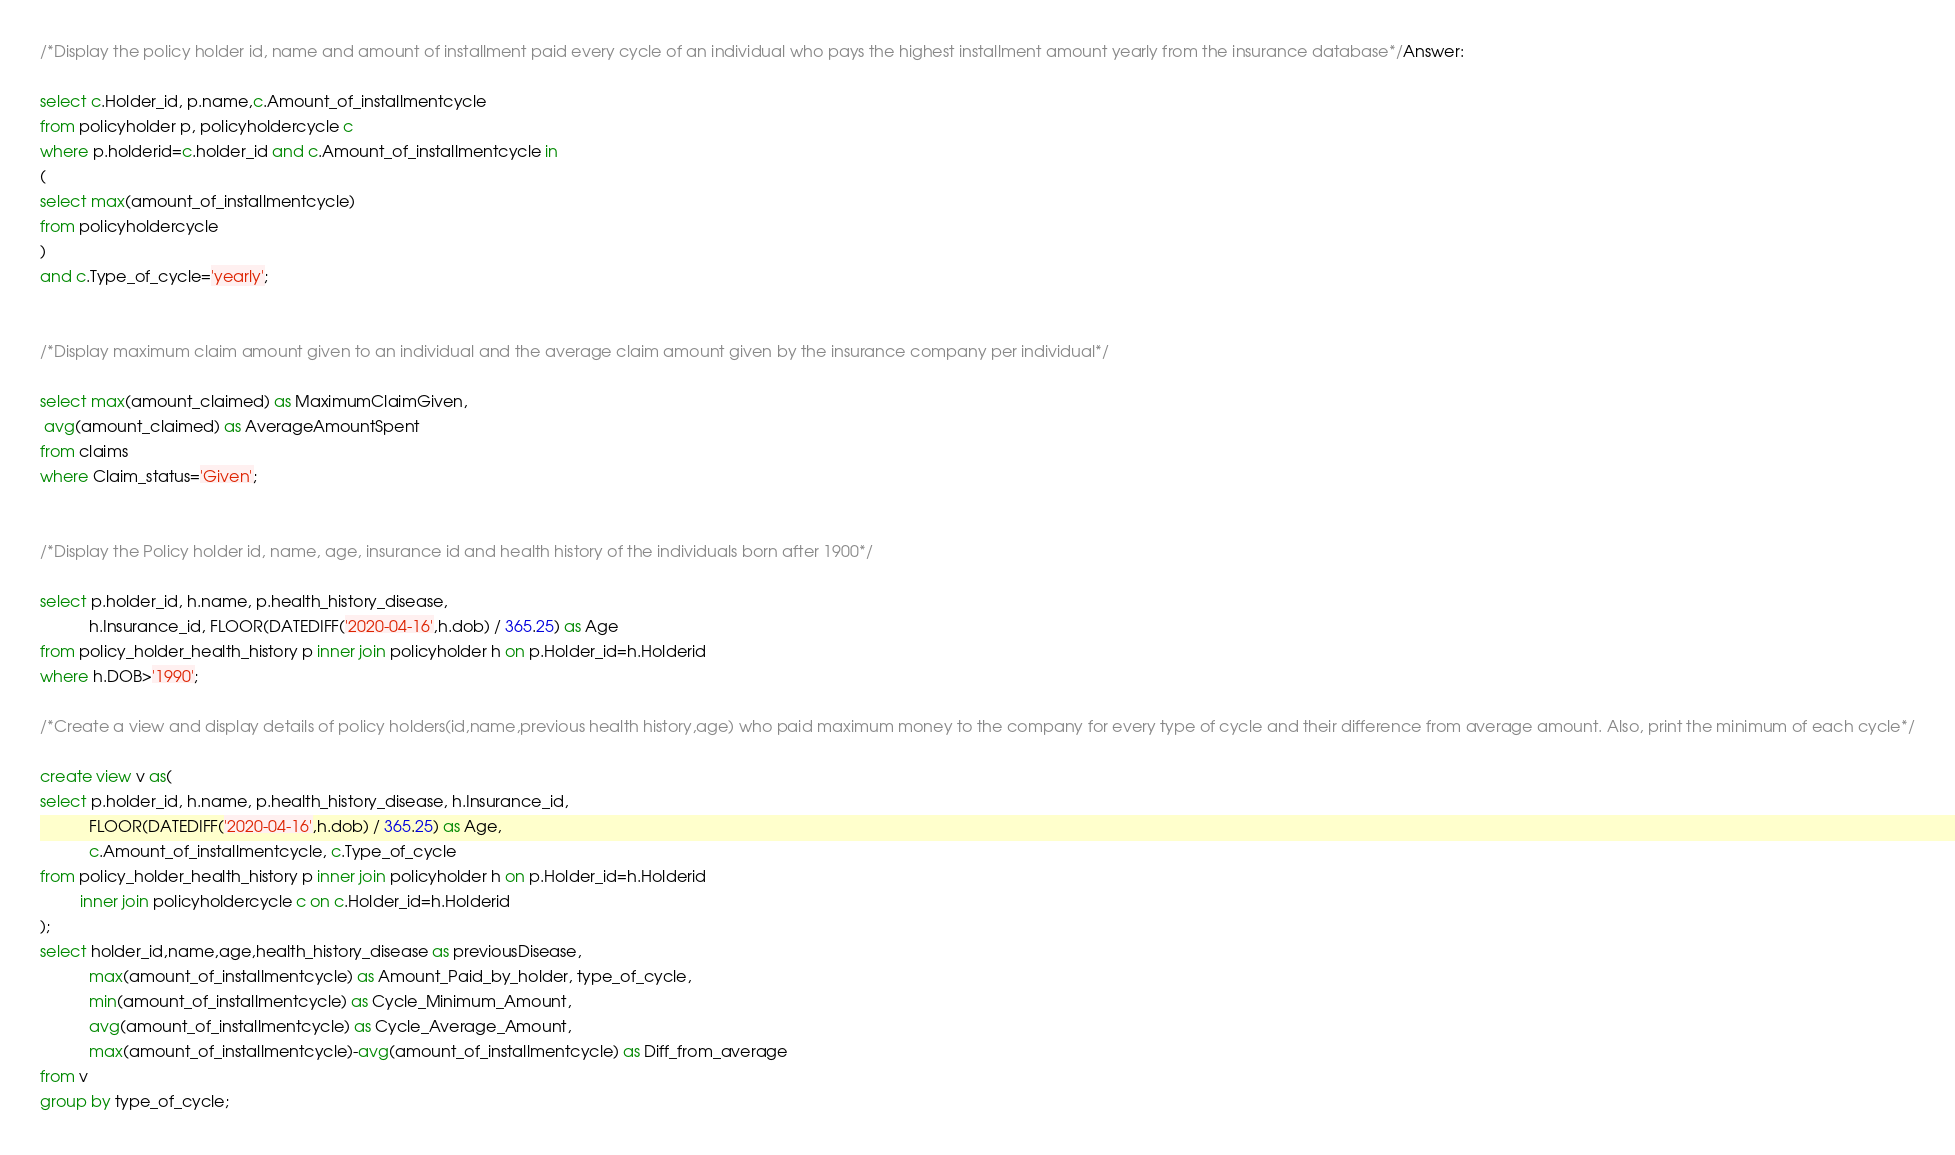<code> <loc_0><loc_0><loc_500><loc_500><_SQL_>/*Display the policy holder id, name and amount of installment paid every cycle of an individual who pays the highest installment amount yearly from the insurance database*/Answer:

select c.Holder_id, p.name,c.Amount_of_installmentcycle
from policyholder p, policyholdercycle c
where p.holderid=c.holder_id and c.Amount_of_installmentcycle in 
(
select max(amount_of_installmentcycle)
from policyholdercycle
)
and c.Type_of_cycle='yearly';


/*Display maximum claim amount given to an individual and the average claim amount given by the insurance company per individual*/

select max(amount_claimed) as MaximumClaimGiven,
 avg(amount_claimed) as AverageAmountSpent
from claims
where Claim_status='Given';


/*Display the Policy holder id, name, age, insurance id and health history of the individuals born after 1900*/

select p.holder_id, h.name, p.health_history_disease,
           h.Insurance_id, FLOOR(DATEDIFF('2020-04-16',h.dob) / 365.25) as Age
from policy_holder_health_history p inner join policyholder h on p.Holder_id=h.Holderid
where h.DOB>'1990';

/*Create a view and display details of policy holders(id,name,previous health history,age) who paid maximum money to the company for every type of cycle and their difference from average amount. Also, print the minimum of each cycle*/

create view v as(
select p.holder_id, h.name, p.health_history_disease, h.Insurance_id,
           FLOOR(DATEDIFF('2020-04-16',h.dob) / 365.25) as Age,
           c.Amount_of_installmentcycle, c.Type_of_cycle
from policy_holder_health_history p inner join policyholder h on p.Holder_id=h.Holderid
         inner join policyholdercycle c on c.Holder_id=h.Holderid
);
select holder_id,name,age,health_history_disease as previousDisease,
           max(amount_of_installmentcycle) as Amount_Paid_by_holder, type_of_cycle,
           min(amount_of_installmentcycle) as Cycle_Minimum_Amount,
           avg(amount_of_installmentcycle) as Cycle_Average_Amount,
           max(amount_of_installmentcycle)-avg(amount_of_installmentcycle) as Diff_from_average
from v
group by type_of_cycle;
</code> 